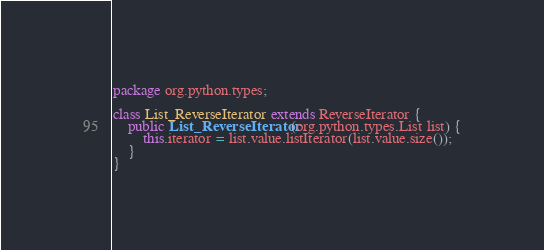Convert code to text. <code><loc_0><loc_0><loc_500><loc_500><_Java_>package org.python.types;

class List_ReverseIterator extends ReverseIterator {
    public List_ReverseIterator(org.python.types.List list) {
        this.iterator = list.value.listIterator(list.value.size());
    }
}
</code> 